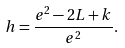Convert formula to latex. <formula><loc_0><loc_0><loc_500><loc_500>h = \frac { e ^ { 2 } - 2 L + k } { e ^ { 2 } } .</formula> 